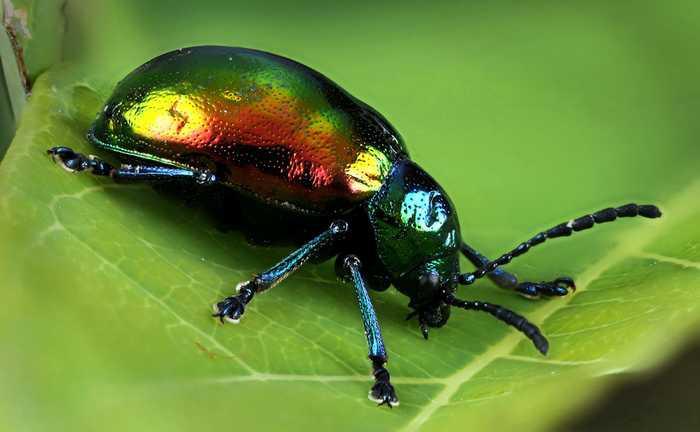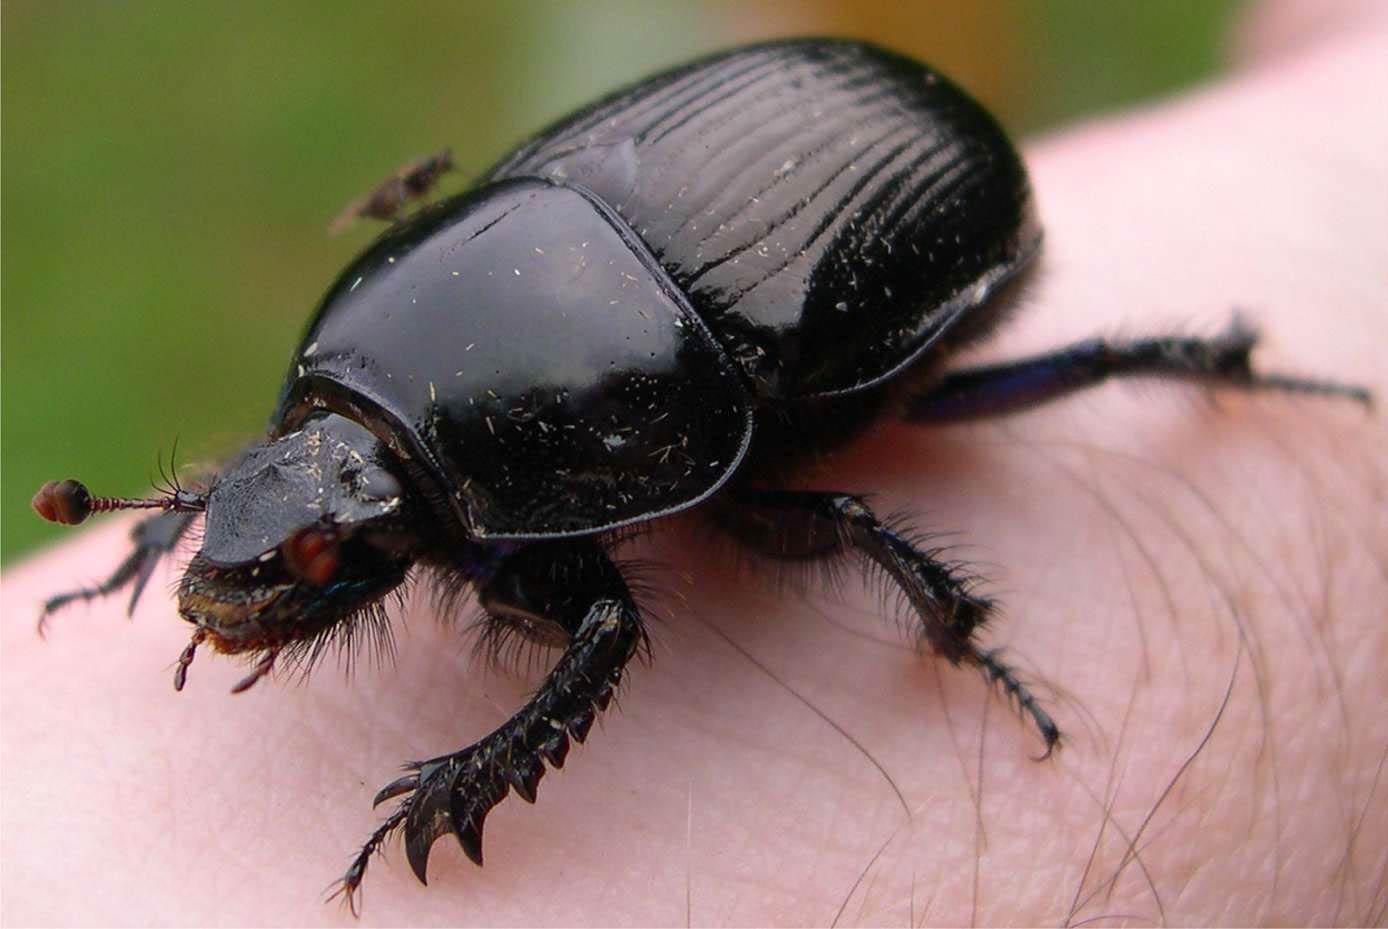The first image is the image on the left, the second image is the image on the right. Assess this claim about the two images: "The insect in one of the images is standing upon a green leaf.". Correct or not? Answer yes or no. Yes. 